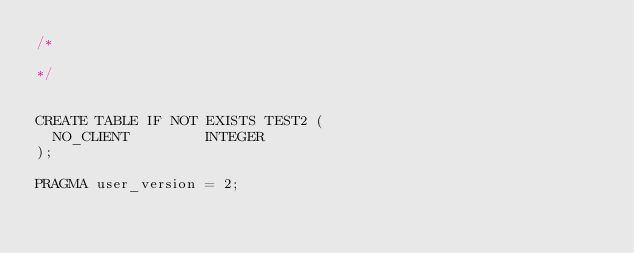Convert code to text. <code><loc_0><loc_0><loc_500><loc_500><_SQL_>/*
      
*/


CREATE TABLE IF NOT EXISTS TEST2 (
  NO_CLIENT         INTEGER
);

PRAGMA user_version = 2;
</code> 